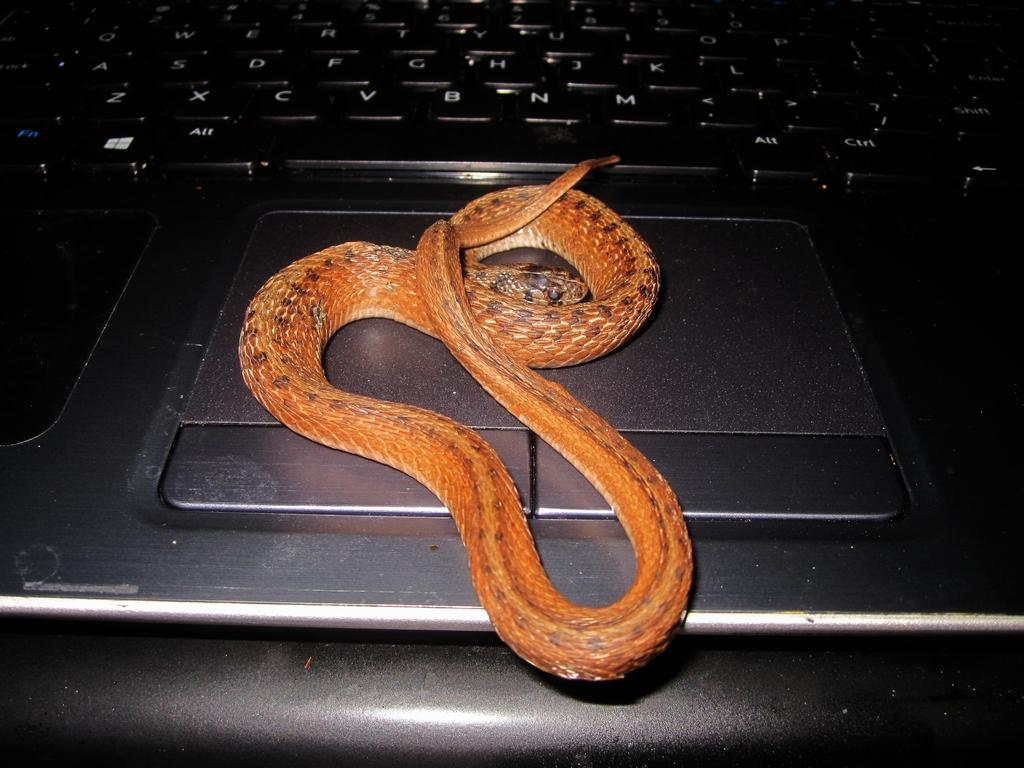What is the main object in the image? There is a laptop keyboard in the image. Is there any living creature in the image? Yes, there is a snake in the image. What is the color of the snake? The snake is orange in color. Are there any specific markings on the snake? Yes, the snake has black dots on it. What type of ground can be seen in the image? There is no ground visible in the image; it features a laptop keyboard and a snake. What type of acoustics can be heard in the image? There is no sound or acoustics present in the image, as it is a still image. 